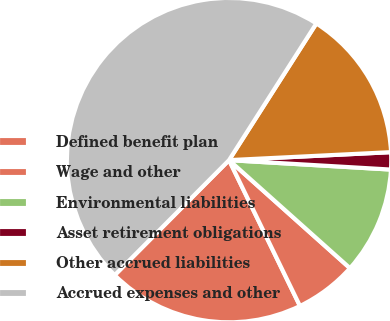<chart> <loc_0><loc_0><loc_500><loc_500><pie_chart><fcel>Defined benefit plan<fcel>Wage and other<fcel>Environmental liabilities<fcel>Asset retirement obligations<fcel>Other accrued liabilities<fcel>Accrued expenses and other<nl><fcel>19.66%<fcel>6.19%<fcel>10.68%<fcel>1.71%<fcel>15.17%<fcel>46.59%<nl></chart> 